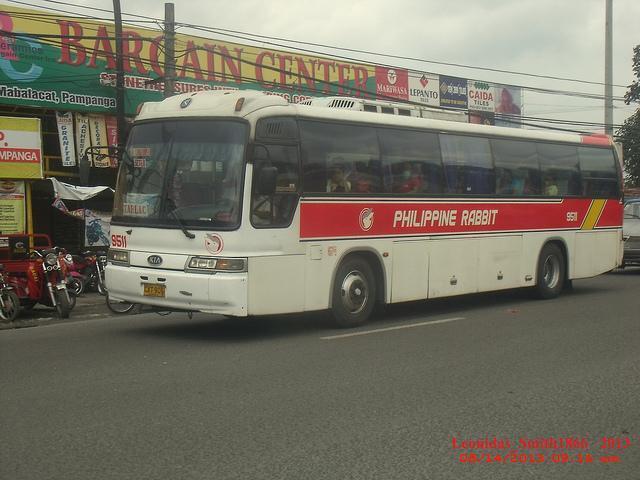How many cats are in the picture?
Give a very brief answer. 0. 